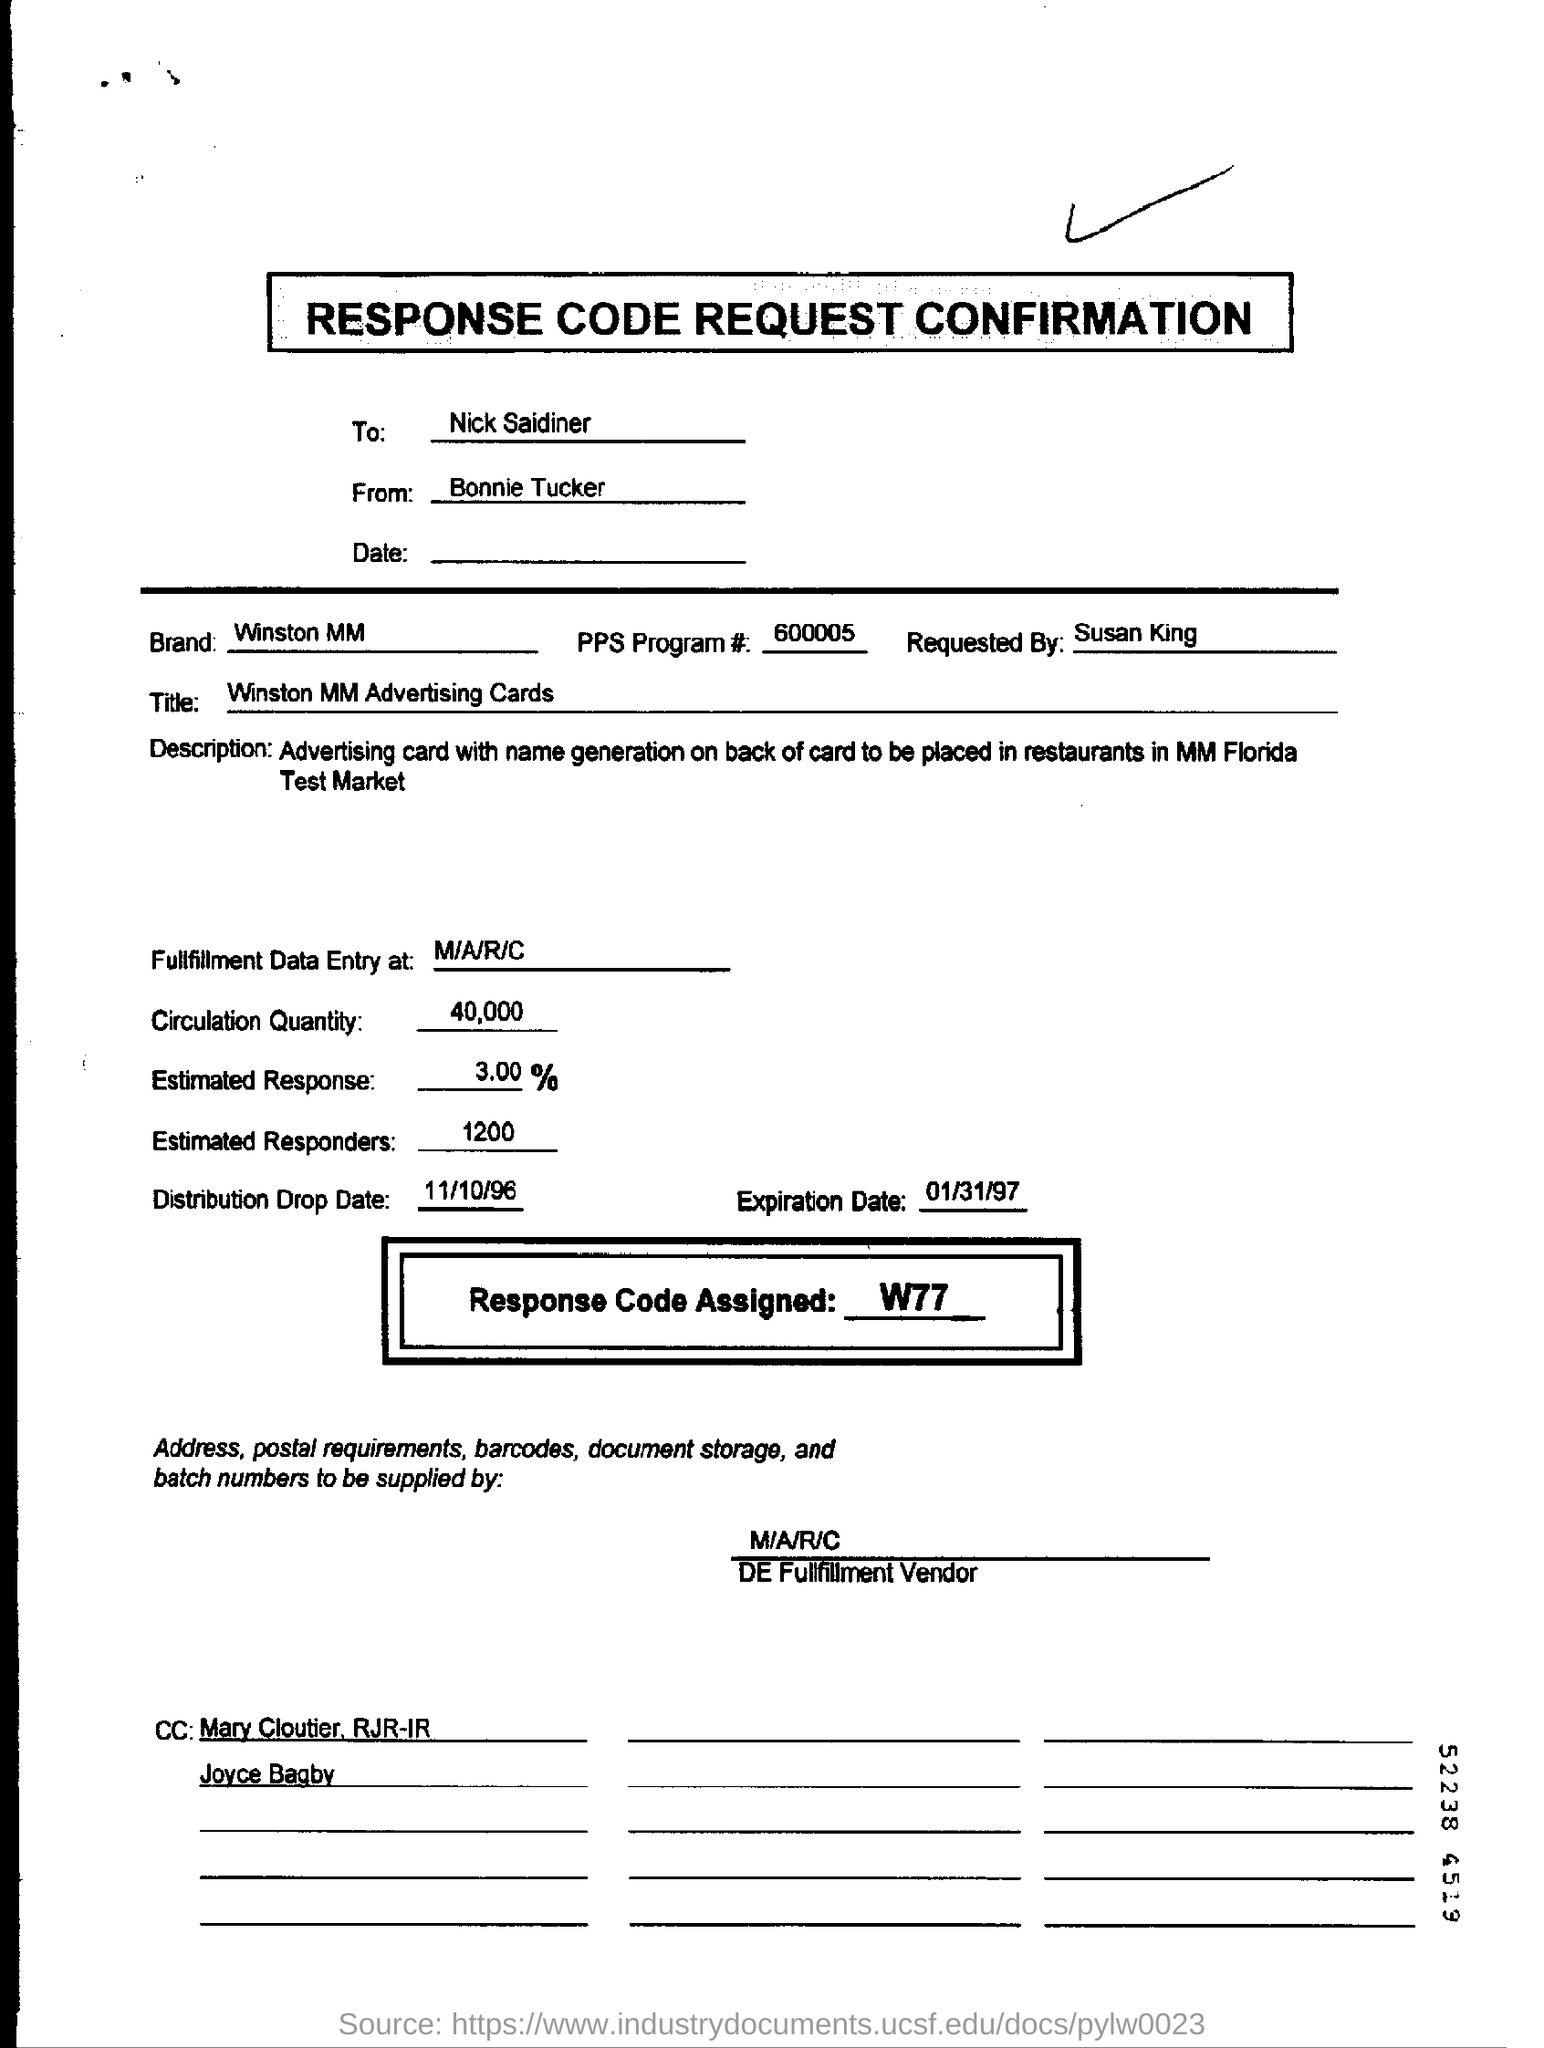What is the expiration date mentioned in the form?
Make the answer very short. 01/31/97. 